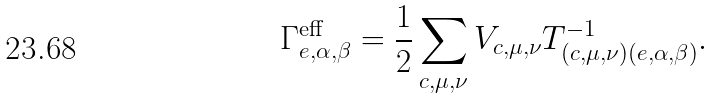<formula> <loc_0><loc_0><loc_500><loc_500>\Gamma _ { e , \alpha , \beta } ^ { \text {eff} } = \frac { 1 } { 2 } \sum _ { c , \mu , \nu } V _ { c , \mu , \nu } T ^ { - 1 } _ { \left ( c , \mu , \nu \right ) \left ( e , \alpha , \beta \right ) } .</formula> 